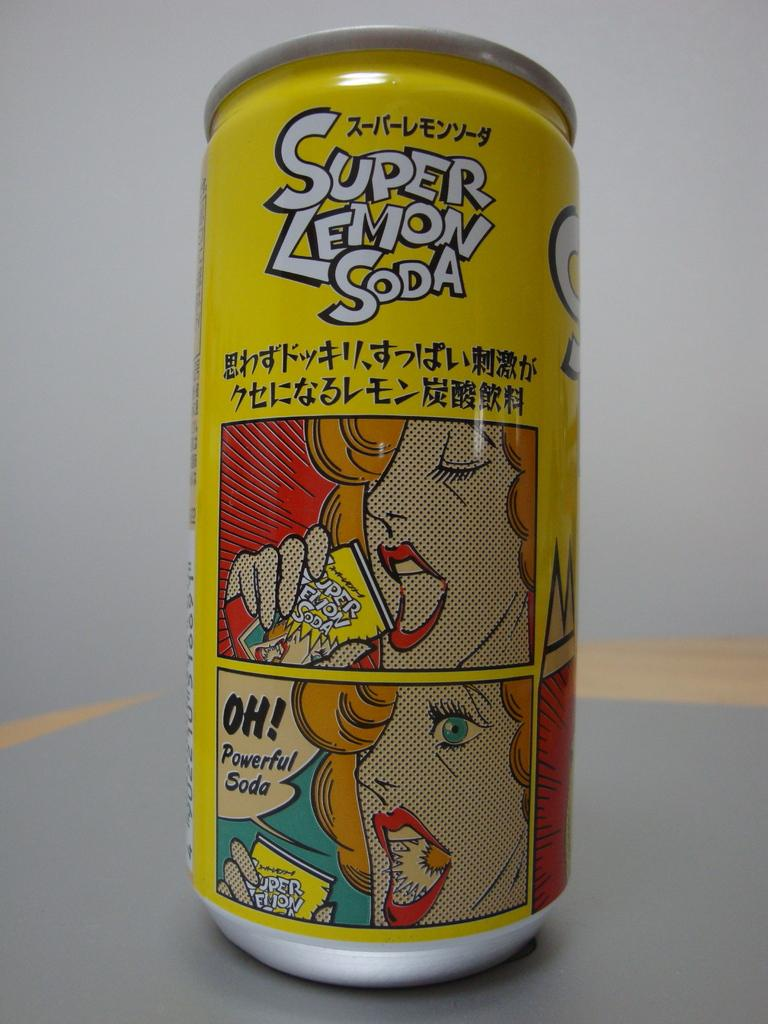Provide a one-sentence caption for the provided image. A yellow aluminum can of Super Lemon Soda on a flat surface. 